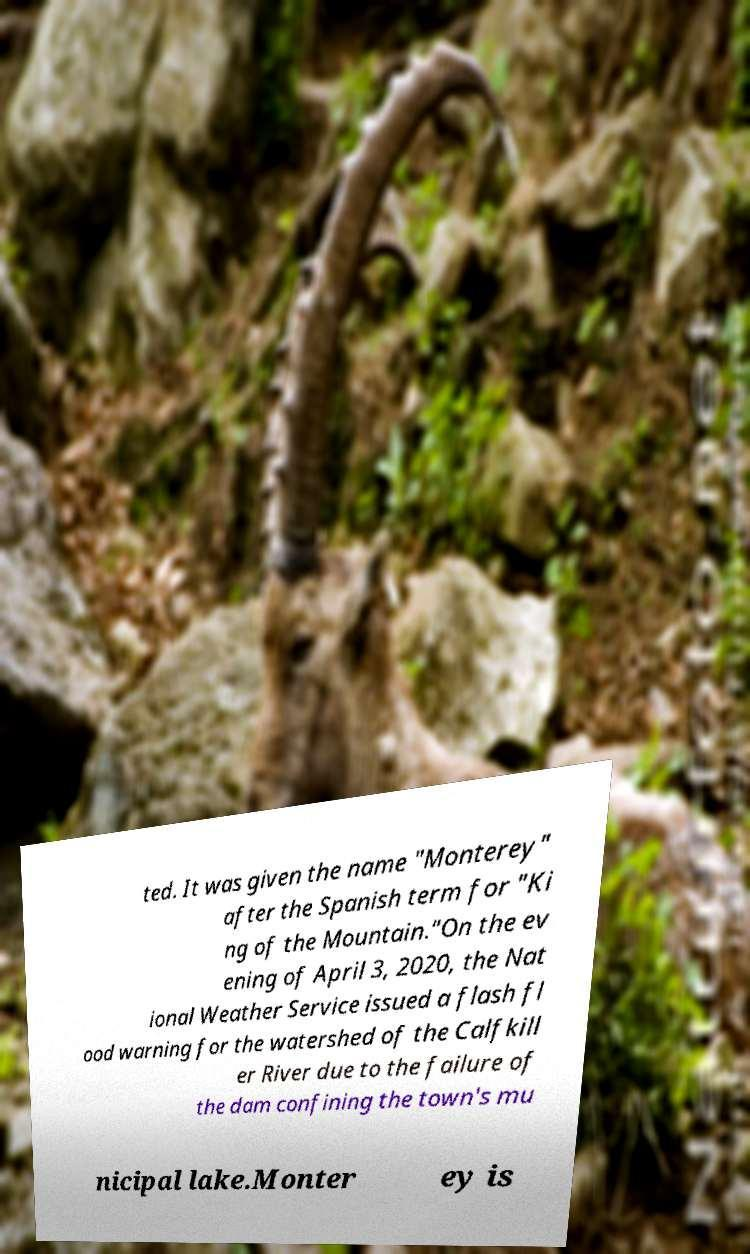For documentation purposes, I need the text within this image transcribed. Could you provide that? ted. It was given the name "Monterey" after the Spanish term for "Ki ng of the Mountain."On the ev ening of April 3, 2020, the Nat ional Weather Service issued a flash fl ood warning for the watershed of the Calfkill er River due to the failure of the dam confining the town's mu nicipal lake.Monter ey is 